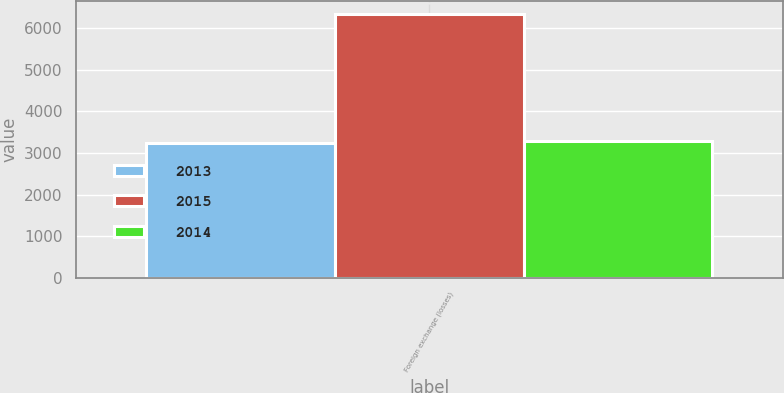Convert chart. <chart><loc_0><loc_0><loc_500><loc_500><stacked_bar_chart><ecel><fcel>Foreign exchange (losses)<nl><fcel>2013<fcel>3238<nl><fcel>2015<fcel>6328<nl><fcel>2014<fcel>3284<nl></chart> 